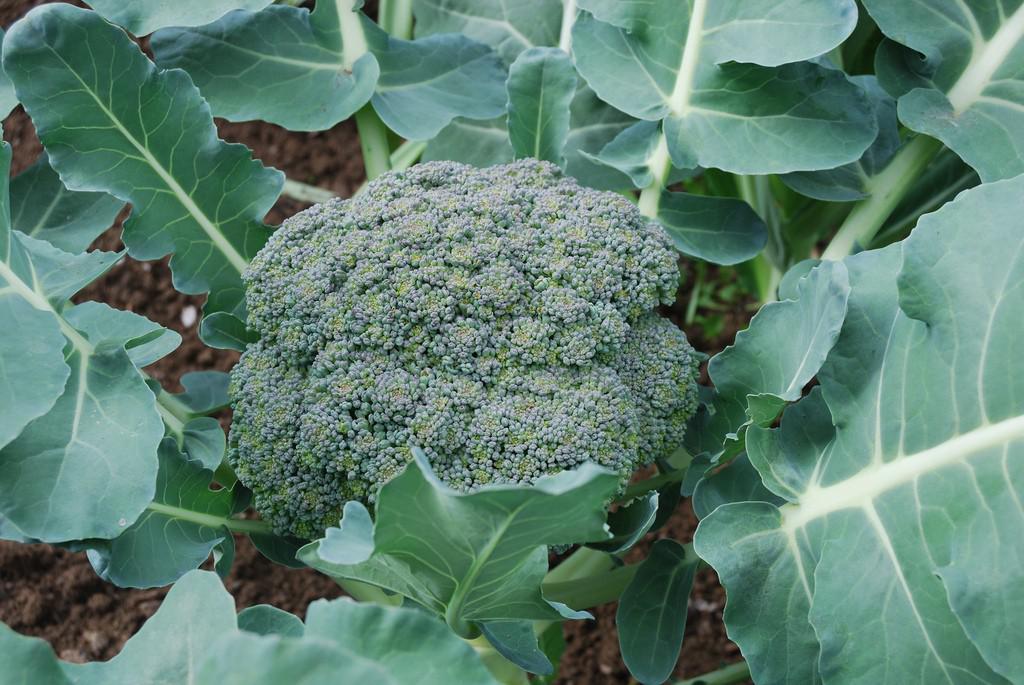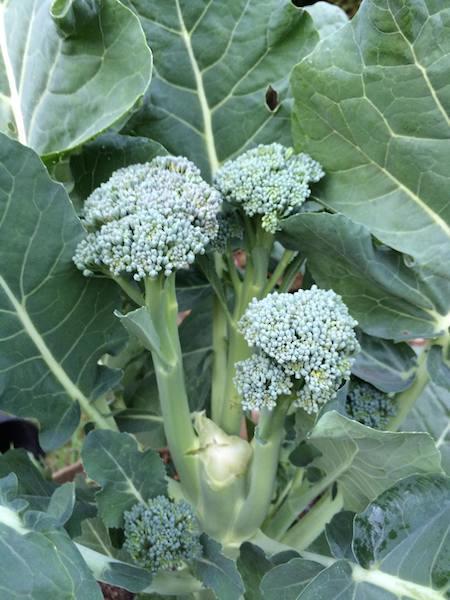The first image is the image on the left, the second image is the image on the right. Considering the images on both sides, is "There is broccoli on a table." valid? Answer yes or no. No. The first image is the image on the left, the second image is the image on the right. Evaluate the accuracy of this statement regarding the images: "The right image shows broccoli on a wooden surface.". Is it true? Answer yes or no. No. 